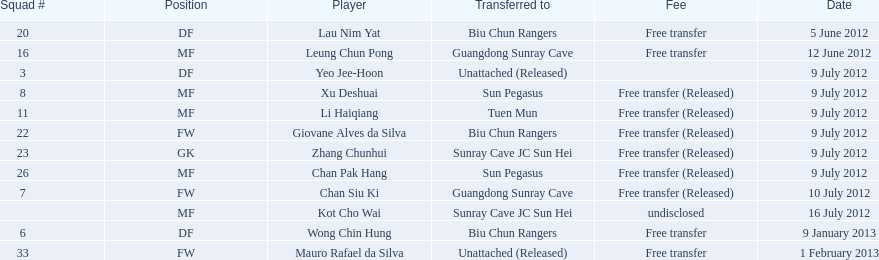When did the non-released free transfers happen? 5 June 2012, 12 June 2012, 9 January 2013, 1 February 2013. On those specific dates, when were players transferred to another team? 5 June 2012, 12 June 2012, 9 January 2013. When were the transfers involving biu chun rangers? 5 June 2012, 9 January 2013. Which of those dates included receiving a df? 9 January 2013. 